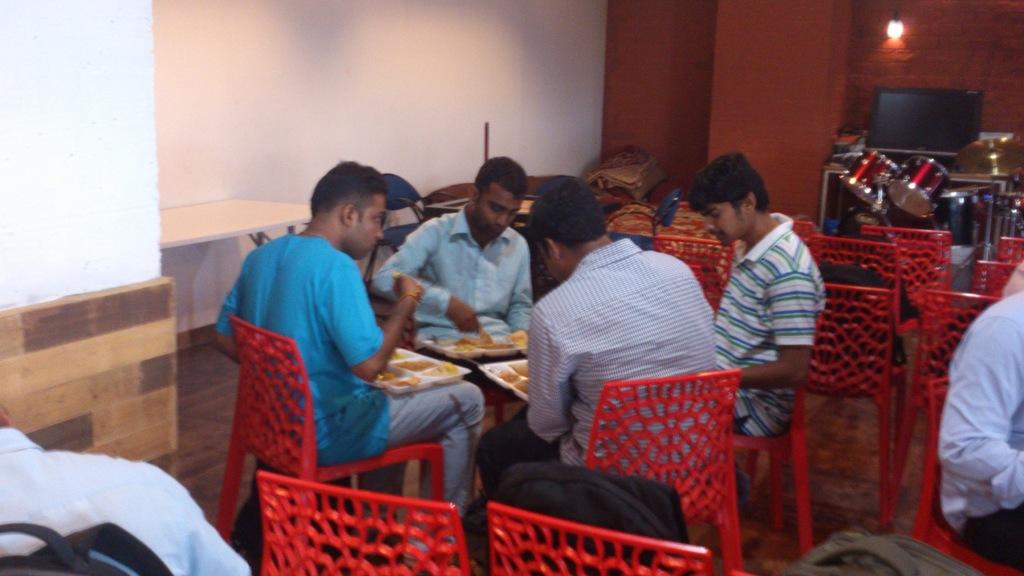How many people are in the image? There is a group of people in the image. What are the people doing in the image? The people are sitting on chairs and holding plates. What objects related to music can be seen in the image? There are drums and a cymbal in the image. What is the source of light in the image? There is a wall with a light in the image. What type of ground is visible in the image? There is no ground visible in the image; it appears to be an indoor setting. What is the opinion of the cymbal on the music being played? The cymbal is an inanimate object and cannot have an opinion on the music being played. 